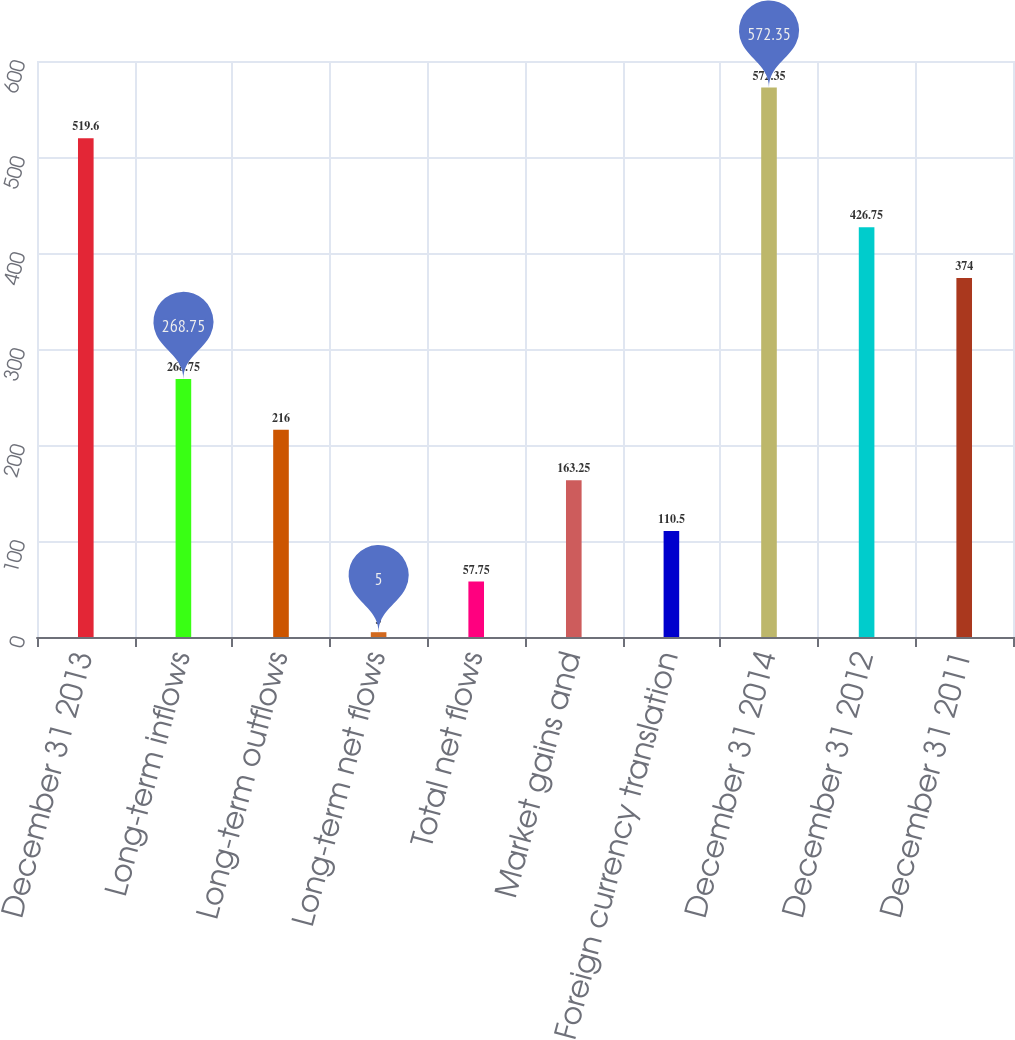<chart> <loc_0><loc_0><loc_500><loc_500><bar_chart><fcel>December 31 2013<fcel>Long-term inflows<fcel>Long-term outflows<fcel>Long-term net flows<fcel>Total net flows<fcel>Market gains and<fcel>Foreign currency translation<fcel>December 31 2014<fcel>December 31 2012<fcel>December 31 2011<nl><fcel>519.6<fcel>268.75<fcel>216<fcel>5<fcel>57.75<fcel>163.25<fcel>110.5<fcel>572.35<fcel>426.75<fcel>374<nl></chart> 